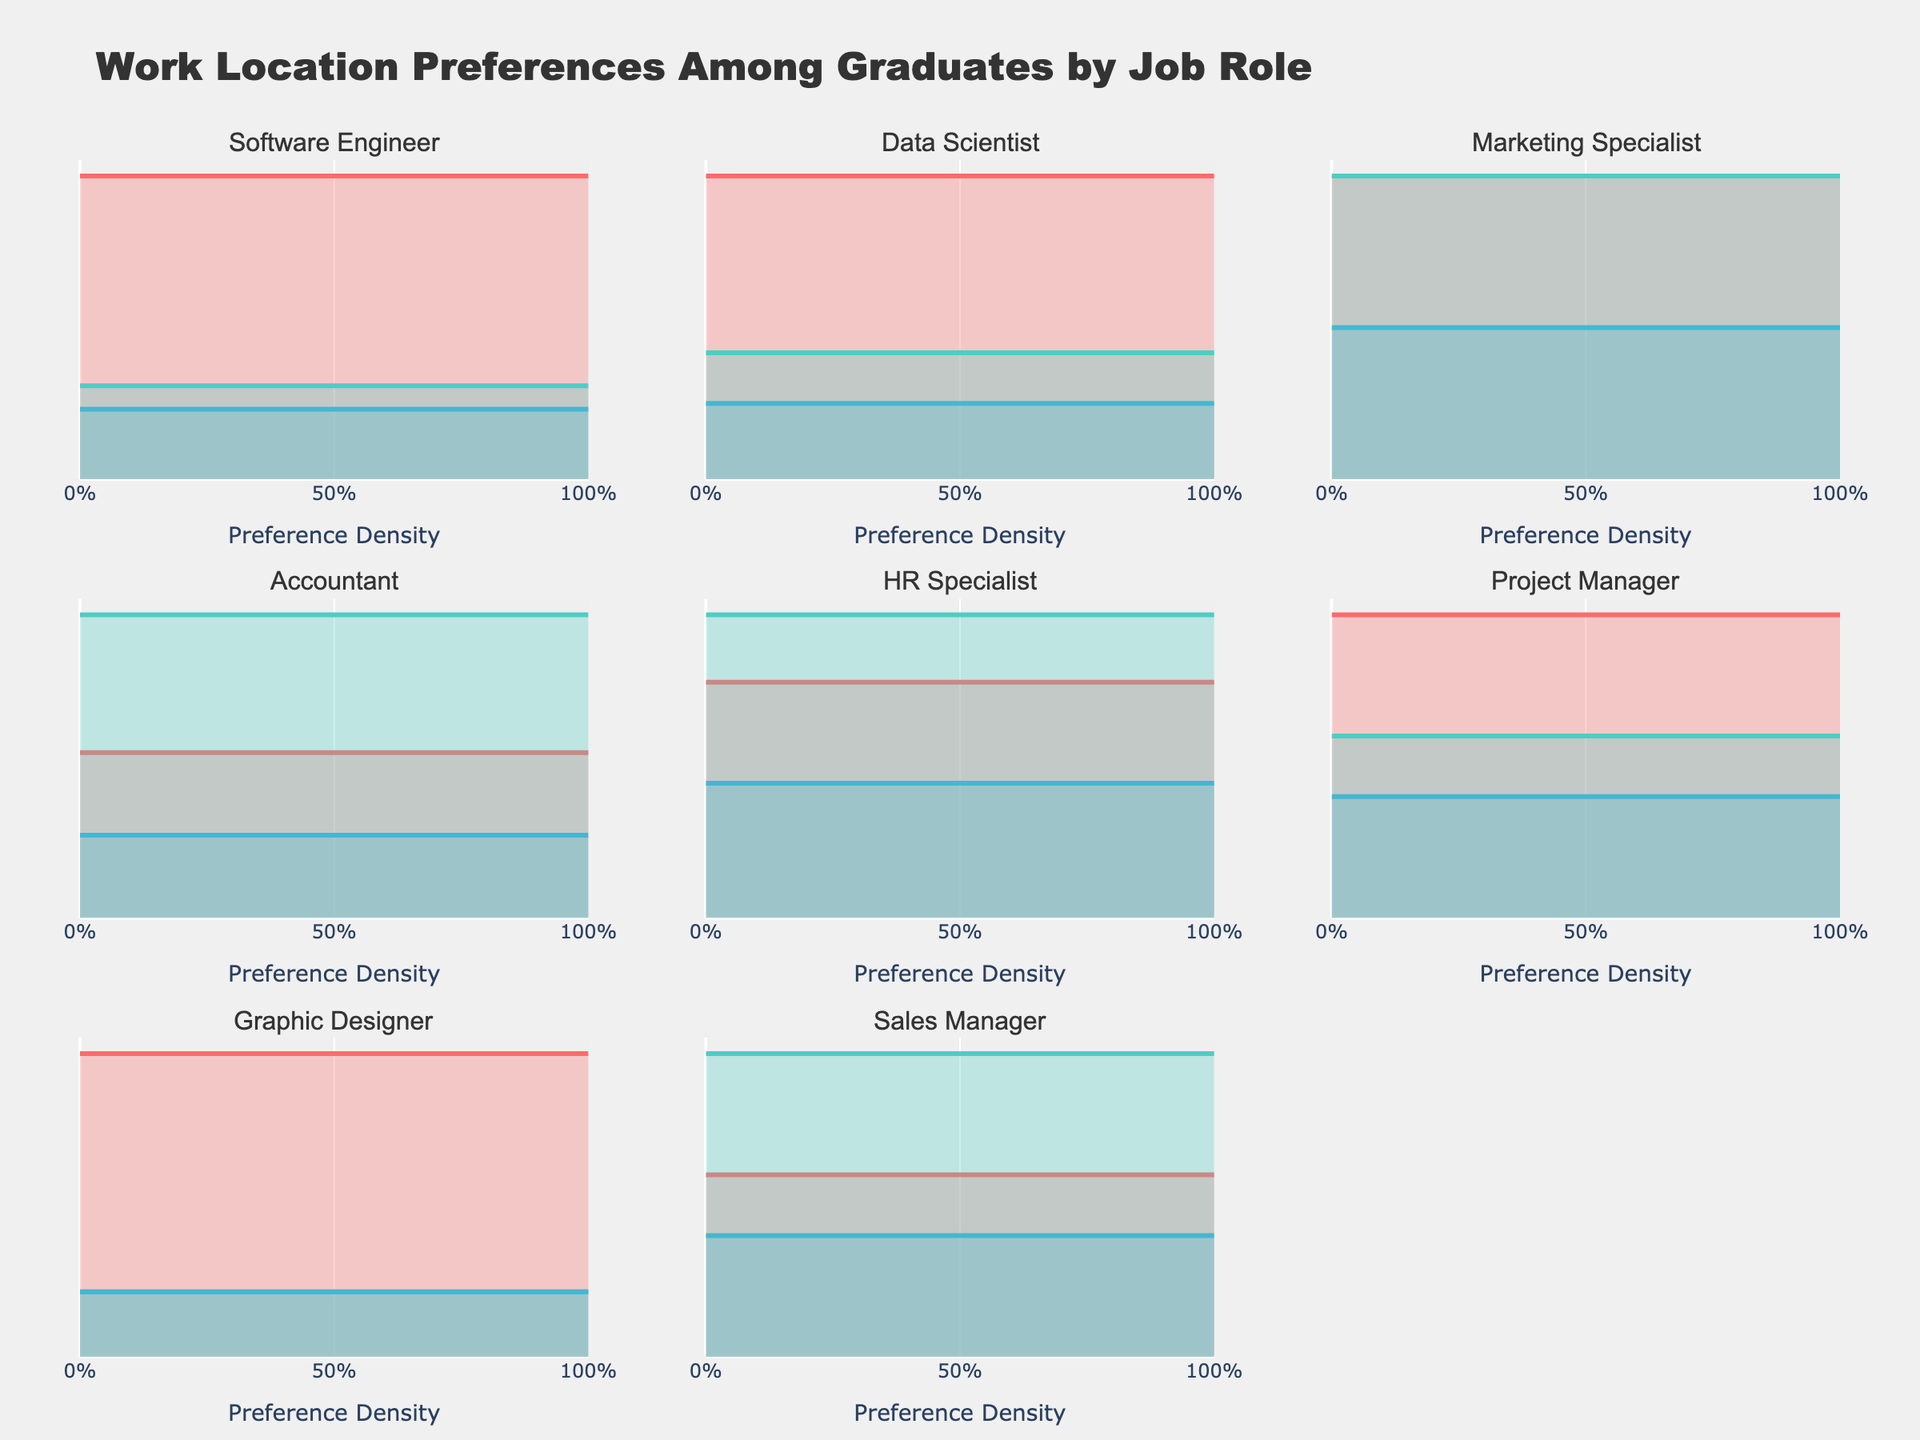What is the title of the plot? The title is usually displayed at the top of the figure. It provides an overview of what the entire figure is about. In this case, the plot's title indicates the content is about graduates' work location preferences by job role.
Answer: Work Location Preferences Among Graduates by Job Role Which job role has the highest preference for remote work? To determine this, look at the subplots for each job role and identify the one with the highest value on the y-axis for the "Remote" line color.
Answer: Graphic Designer Which work location is least preferred by Software Engineers? Check the subplot for Software Engineers. Among the densities for remote, on-site, and hybrid, the one with the lowest value is the least preferred.
Answer: Hybrid Compare the preference for on-site work between Accountants and Sales Managers. Which group prefers it more? To compare, look at the subplots for both Accountants and Sales Managers. Compare the y-axis values of the "On-Site" lines for both roles.
Answer: Accountants For the Data Scientist role, what is the difference in preference densities between remote work and on-site work? Find the subplot for the Data Scientist. Note the density values for remote and on-site and calculate the difference (0.60 - 0.25).
Answer: 0.35 Which job role shows an equal preference for remote and on-site work? Identify the subplot where the y-axis values (heights of the lines) for both remote and on-site work are equal.
Answer: Marketing Specialist Arrange the job roles in descending order of their preference density for hybrid work. Examine each subplot and list down the density values for hybrid work. Then, sort them in descending order.
Answer: Sales Manager, Marketing Specialist, HR Specialist, Software Engineer/Data Scientist/Graphic Designer/Accountant/Project Manager What is the combined preference density for on-site work for Project Managers and HR Specialists? Find the on-site density values for both Project Managers and HR Specialists and sum them up (0.30 + 0.45).
Answer: 0.75 